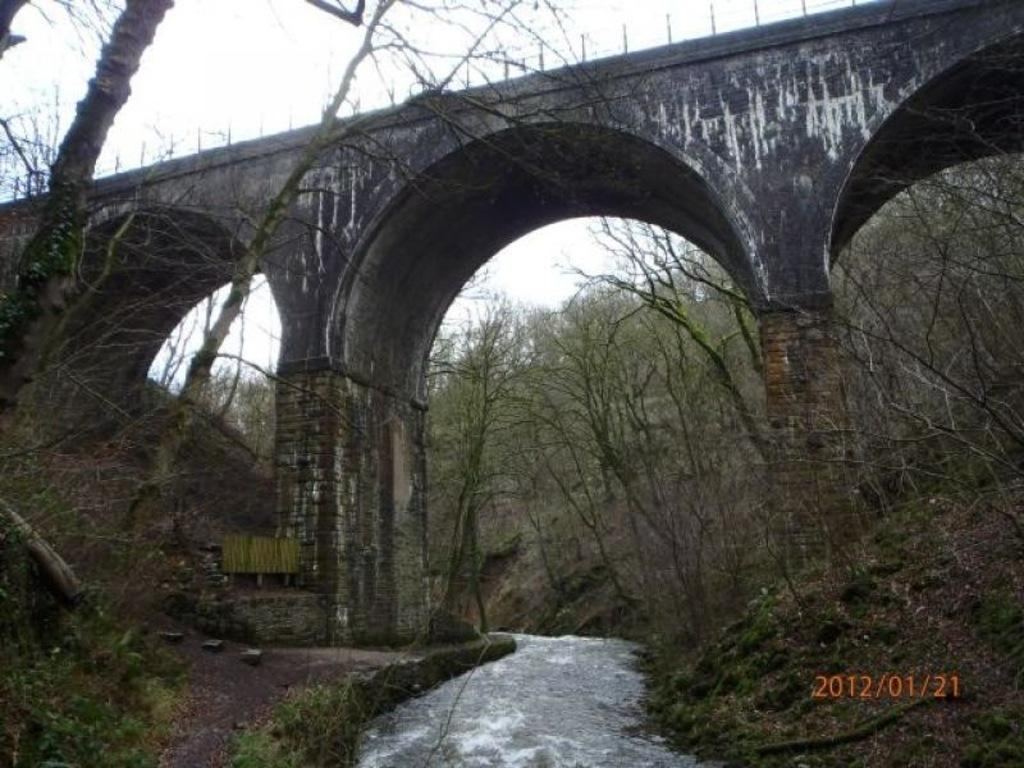What type of terrain can be seen in the image? Ground and water are visible in the image. What type of vegetation is present in the image? There are trees in the image. What structure is present in the image? There is a bridge in the image. What is the color of the bridge? The bridge is black and white in color. What is visible in the background of the image? The sky is visible in the background of the image. How many crackers are floating on the water in the image? There are no crackers present in the image; it features ground, water, trees, a bridge, and the sky. What is the size of the pot in the image? There is no pot present in the image. 